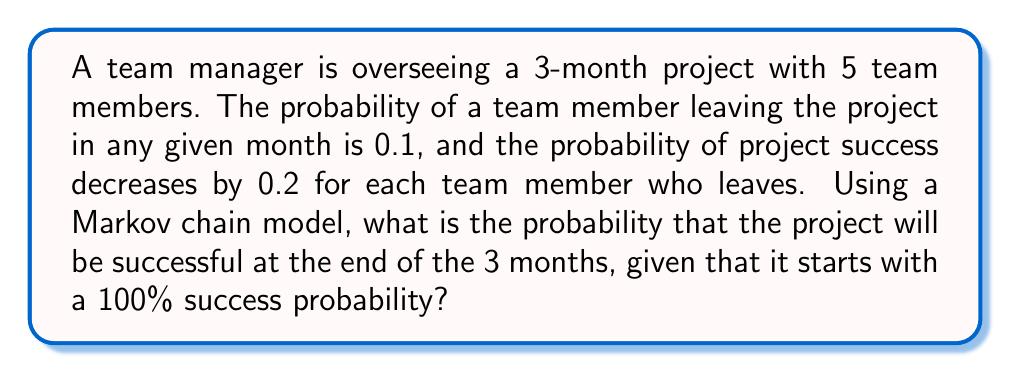Give your solution to this math problem. Let's approach this step-by-step using a Markov chain model:

1) First, we need to define our states. Let's represent them as the number of team members remaining:
   State 5: 5 members (initial state)
   State 4: 4 members
   State 3: 3 members
   State 2: 2 members
   State 1: 1 member
   State 0: 0 members

2) Now, let's create the transition probability matrix P:

   $$P = \begin{bmatrix}
   0.59049 & 0.32805 & 0.07290 & 0.00810 & 0.00045 & 0.00001 \\
   0 & 0.72900 & 0.24300 & 0.02700 & 0.00100 & 0 \\
   0 & 0 & 0.72900 & 0.24300 & 0.02700 & 0.00100 \\
   0 & 0 & 0 & 0.72900 & 0.24300 & 0.02800 \\
   0 & 0 & 0 & 0 & 0.72900 & 0.27100 \\
   0 & 0 & 0 & 0 & 0 & 1
   \end{bmatrix}$$

   This matrix represents the probability of transitioning from one state to another over the course of one month.

3) To find the state probabilities after 3 months, we need to calculate $P^3$:

   $$P^3 = \begin{bmatrix}
   0.20590 & 0.34316 & 0.28597 & 0.13199 & 0.02986 & 0.00312 \\
   0 & 0.38770 & 0.38770 & 0.17676 & 0.04253 & 0.00531 \\
   0 & 0 & 0.38770 & 0.38770 & 0.17676 & 0.04784 \\
   0 & 0 & 0 & 0.38770 & 0.38770 & 0.22460 \\
   0 & 0 & 0 & 0 & 0.38770 & 0.61230 \\
   0 & 0 & 0 & 0 & 0 & 1
   \end{bmatrix}$$

4) The first row of $P^3$ gives us the probabilities of ending up in each state after 3 months, starting from state 5.

5) Now, let's calculate the success probability for each state:
   State 5: 100% = 1.0
   State 4: 80% = 0.8
   State 3: 60% = 0.6
   State 2: 40% = 0.4
   State 1: 20% = 0.2
   State 0: 0% = 0.0

6) The overall success probability is the sum of the products of each state's probability and its corresponding success probability:

   $$(0.20590 * 1.0) + (0.34316 * 0.8) + (0.28597 * 0.6) + (0.13199 * 0.4) + (0.02986 * 0.2) + (0.00312 * 0.0)$$

7) Calculating this sum:

   $$0.20590 + 0.27453 + 0.17158 + 0.05280 + 0.00597 + 0 = 0.71078$$

Therefore, the probability of project success after 3 months is approximately 0.71078 or 71.078%.
Answer: 0.71078 